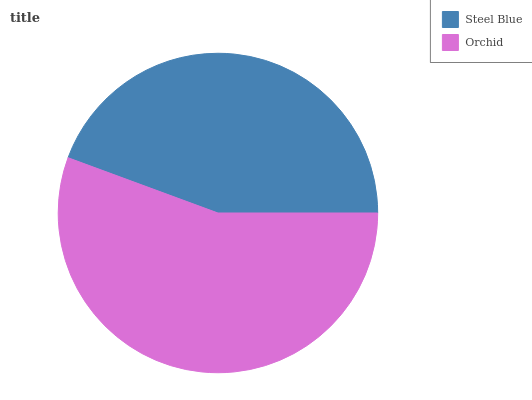Is Steel Blue the minimum?
Answer yes or no. Yes. Is Orchid the maximum?
Answer yes or no. Yes. Is Orchid the minimum?
Answer yes or no. No. Is Orchid greater than Steel Blue?
Answer yes or no. Yes. Is Steel Blue less than Orchid?
Answer yes or no. Yes. Is Steel Blue greater than Orchid?
Answer yes or no. No. Is Orchid less than Steel Blue?
Answer yes or no. No. Is Orchid the high median?
Answer yes or no. Yes. Is Steel Blue the low median?
Answer yes or no. Yes. Is Steel Blue the high median?
Answer yes or no. No. Is Orchid the low median?
Answer yes or no. No. 